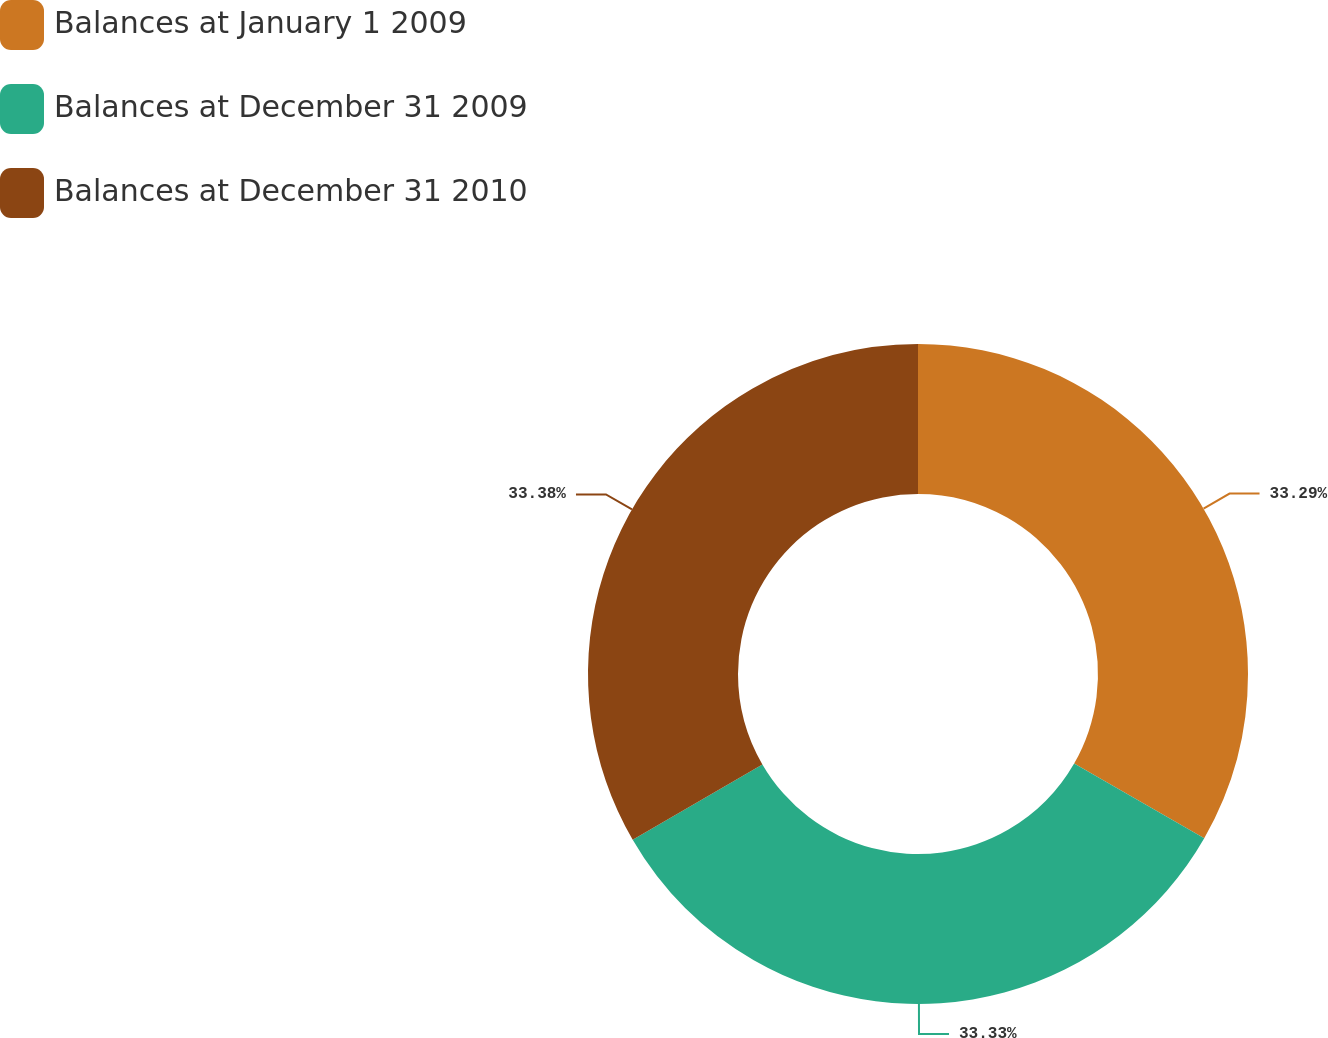Convert chart to OTSL. <chart><loc_0><loc_0><loc_500><loc_500><pie_chart><fcel>Balances at January 1 2009<fcel>Balances at December 31 2009<fcel>Balances at December 31 2010<nl><fcel>33.29%<fcel>33.33%<fcel>33.38%<nl></chart> 